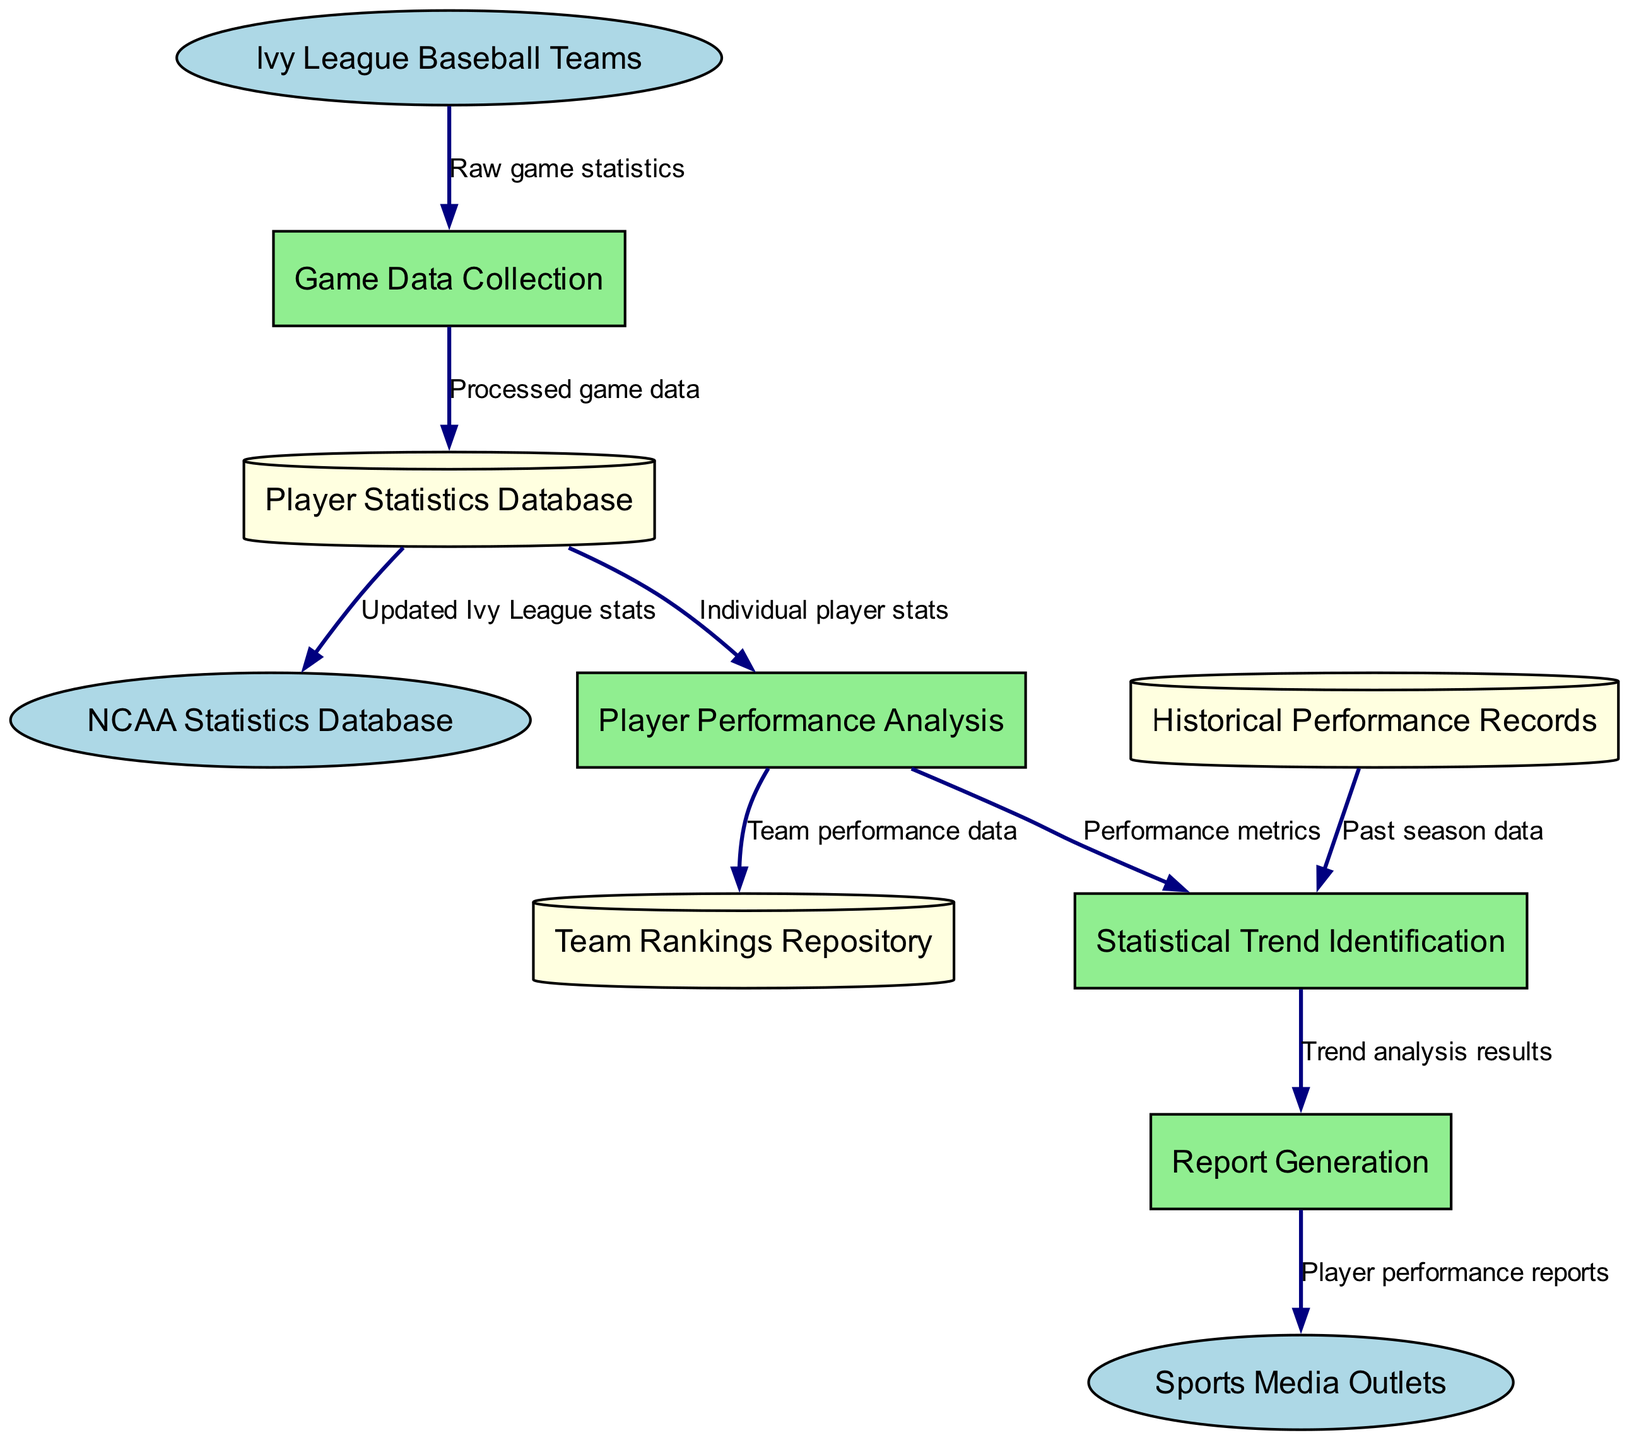What are the external entities in the diagram? The external entities are listed at the top of the diagram and include all the parties, such as "Ivy League Baseball Teams," "NCAA Statistics Database," and "Sports Media Outlets."
Answer: Ivy League Baseball Teams, NCAA Statistics Database, Sports Media Outlets How many processes are included in the diagram? By counting the number of unique process nodes listed in the diagram, which are "Game Data Collection," "Player Performance Analysis," "Statistical Trend Identification," and "Report Generation," we find there are four processes.
Answer: 4 What data flow comes from the "Player Performance Analysis" process? Examining the data flows, the flow that originates from "Player Performance Analysis" heads towards both "Statistical Trend Identification" and "Team Rankings Repository." Therefore, there are two distinct flows, but for the sake of this question, we will take the first one directed to "Statistical Trend Identification."
Answer: Performance metrics Which data store receives updated statistics from the player statistics database? The data flows indicate that the "Player Statistics Database" sends updated statistics specifically to the "NCAA Statistics Database," as referenced in one of the flows depicted in the diagram.
Answer: NCAA Statistics Database What is the purpose of the "Report Generation" process? The "Report Generation" process receives data from "Statistical Trend Identification" and subsequently sends "Player performance reports" to "Sports Media Outlets," indicating its role is to generate and disseminate reports concerning player performance.
Answer: Player performance reports What type of data is stored in the "Historical Performance Records"? Referring to the data flows illustrated in the diagram, "Historical Performance Records" is used for providing "Past season data" to the "Statistical Trend Identification" process, which indicates the kind of data it holds.
Answer: Past season data How many data flows are present in the diagram? By observing the arrows connecting nodes in the diagram, we can count a total of eight distinct data flows linking various elements, showing the interaction and information transfer between them.
Answer: 8 Which external entity receives reports from the "Report Generation" process? The "Report Generation" process sends its output, labeled "Player performance reports," specifically to the "Sports Media Outlets," which is an external entity meant to receive this information.
Answer: Sports Media Outlets 